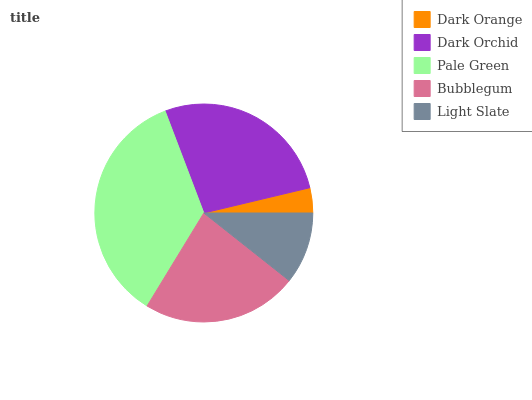Is Dark Orange the minimum?
Answer yes or no. Yes. Is Pale Green the maximum?
Answer yes or no. Yes. Is Dark Orchid the minimum?
Answer yes or no. No. Is Dark Orchid the maximum?
Answer yes or no. No. Is Dark Orchid greater than Dark Orange?
Answer yes or no. Yes. Is Dark Orange less than Dark Orchid?
Answer yes or no. Yes. Is Dark Orange greater than Dark Orchid?
Answer yes or no. No. Is Dark Orchid less than Dark Orange?
Answer yes or no. No. Is Bubblegum the high median?
Answer yes or no. Yes. Is Bubblegum the low median?
Answer yes or no. Yes. Is Dark Orange the high median?
Answer yes or no. No. Is Dark Orange the low median?
Answer yes or no. No. 